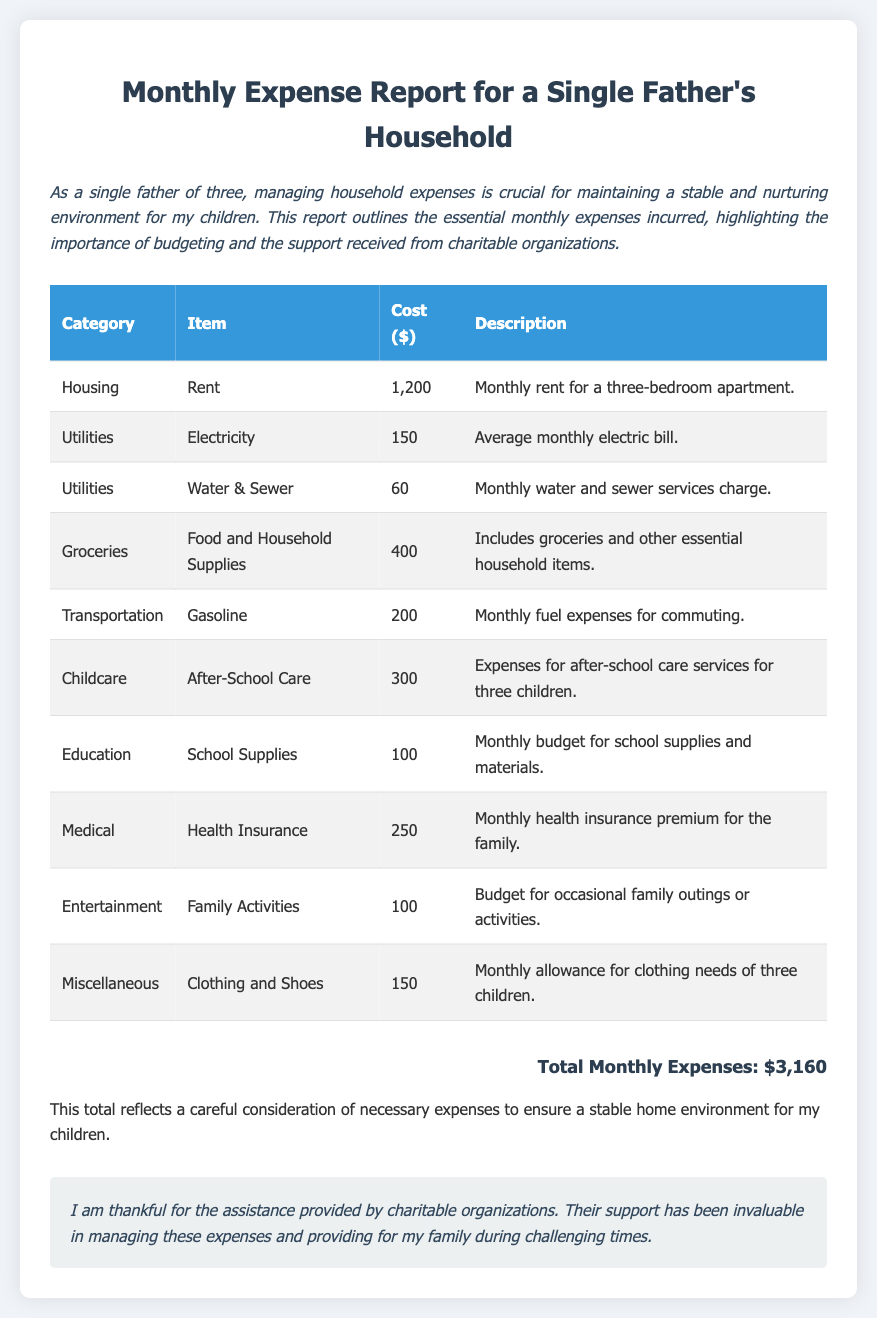What is the total monthly expense? The total monthly expense is mentioned at the bottom of the document, which sums all individual costs.
Answer: $3,160 How much is allocated for rent? The itemized costs in the housing category specify the rent amount.
Answer: $1,200 What is the monthly cost for after-school care? The childcare category outlines the expense for after-school care services for the children.
Answer: $300 How much is spent on groceries? The groceries section provides the total cost for food and household supplies.
Answer: $400 What is the monthly health insurance premium? The medical section clearly states the cost associated with health insurance in the family.
Answer: $250 Which category has the highest expense in the report? Analyzing the individual costs, the housing category with rent is the highest.
Answer: Housing What percentage of total expenses does childcare represent? Calculating the fraction of childcare costs in relation to total expenses gives the percentage.
Answer: 9.46% What types of expenses are included under utilities? The utilities section lists the specific items for electricity and water & sewer.
Answer: Electricity and Water & Sewer What is the description for the clothing and shoes expenses? The miscellaneous section describes the monthly allowance for clothing needs.
Answer: Monthly allowance for clothing needs of three children 